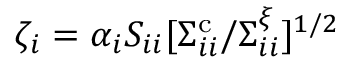Convert formula to latex. <formula><loc_0><loc_0><loc_500><loc_500>\zeta _ { i } = \alpha _ { i } S _ { i i } [ \Sigma _ { i i } ^ { c } / \Sigma _ { i i } ^ { \xi } ] ^ { 1 / 2 }</formula> 